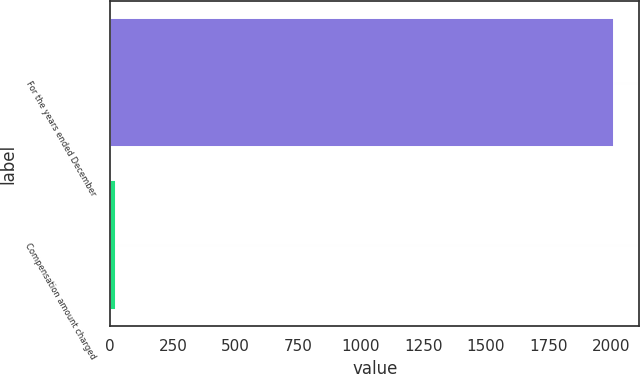Convert chart to OTSL. <chart><loc_0><loc_0><loc_500><loc_500><bar_chart><fcel>For the years ended December<fcel>Compensation amount charged<nl><fcel>2011<fcel>22.5<nl></chart> 